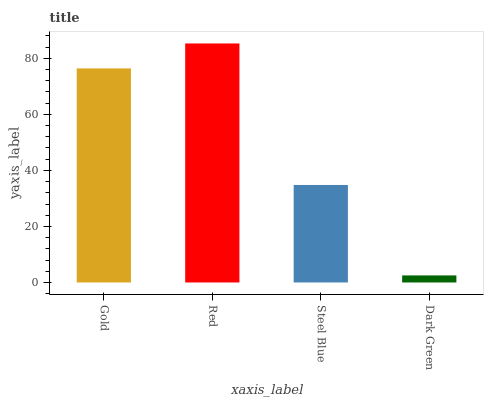Is Dark Green the minimum?
Answer yes or no. Yes. Is Red the maximum?
Answer yes or no. Yes. Is Steel Blue the minimum?
Answer yes or no. No. Is Steel Blue the maximum?
Answer yes or no. No. Is Red greater than Steel Blue?
Answer yes or no. Yes. Is Steel Blue less than Red?
Answer yes or no. Yes. Is Steel Blue greater than Red?
Answer yes or no. No. Is Red less than Steel Blue?
Answer yes or no. No. Is Gold the high median?
Answer yes or no. Yes. Is Steel Blue the low median?
Answer yes or no. Yes. Is Steel Blue the high median?
Answer yes or no. No. Is Gold the low median?
Answer yes or no. No. 